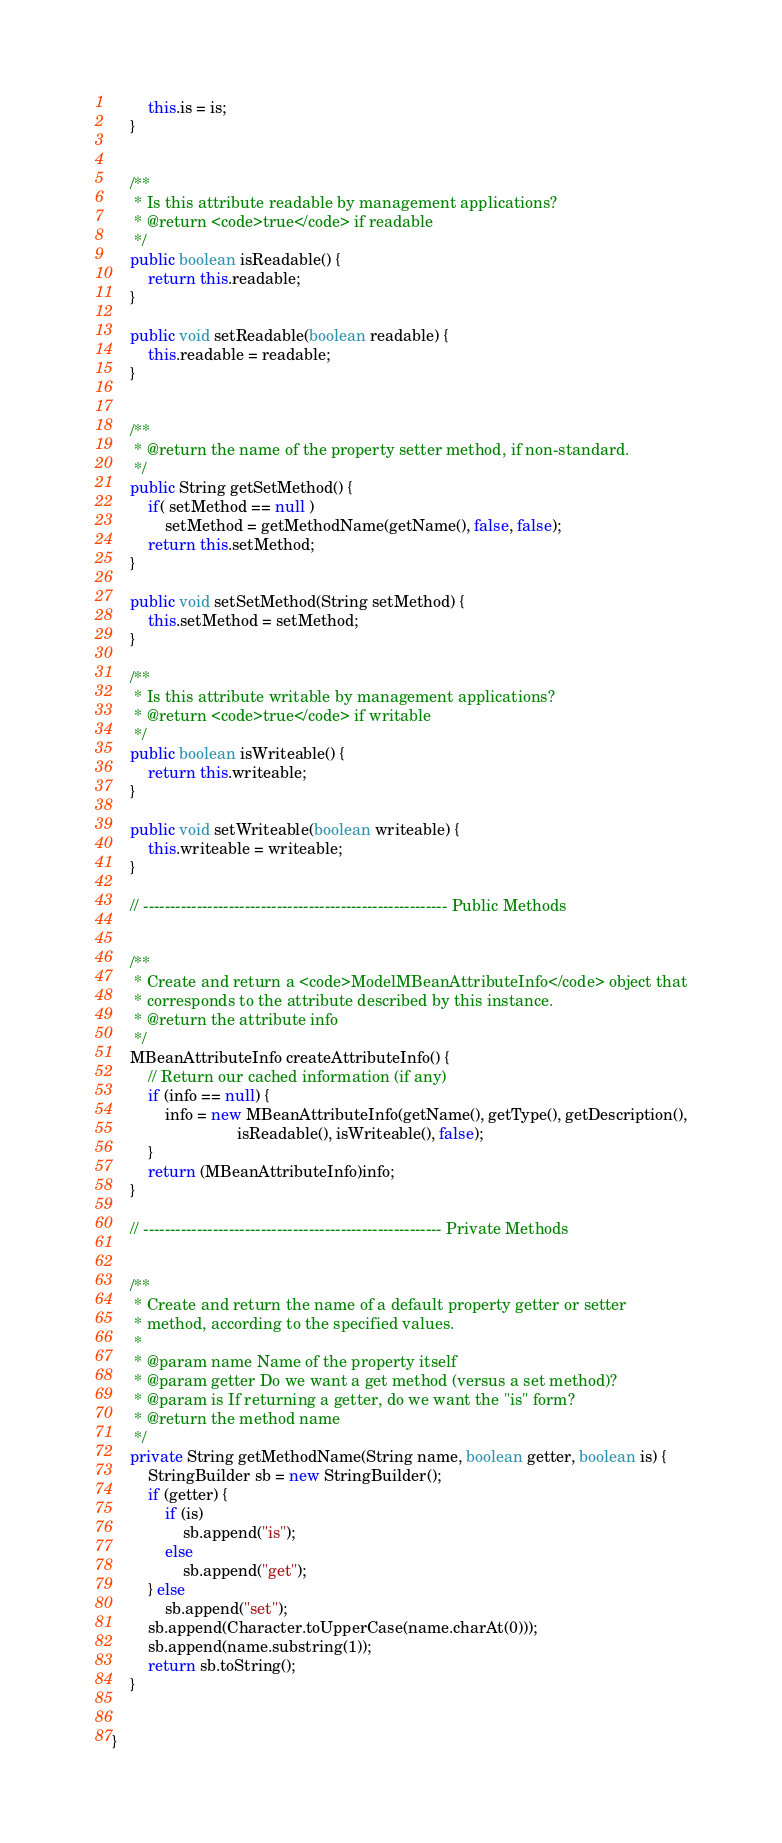<code> <loc_0><loc_0><loc_500><loc_500><_Java_>        this.is = is;
    }


    /**
     * Is this attribute readable by management applications?
     * @return <code>true</code> if readable
     */
    public boolean isReadable() {
        return this.readable;
    }

    public void setReadable(boolean readable) {
        this.readable = readable;
    }


    /**
     * @return the name of the property setter method, if non-standard.
     */
    public String getSetMethod() {
        if( setMethod == null )
            setMethod = getMethodName(getName(), false, false);
        return this.setMethod;
    }

    public void setSetMethod(String setMethod) {
        this.setMethod = setMethod;
    }

    /**
     * Is this attribute writable by management applications?
     * @return <code>true</code> if writable
     */
    public boolean isWriteable() {
        return this.writeable;
    }

    public void setWriteable(boolean writeable) {
        this.writeable = writeable;
    }

    // --------------------------------------------------------- Public Methods


    /**
     * Create and return a <code>ModelMBeanAttributeInfo</code> object that
     * corresponds to the attribute described by this instance.
     * @return the attribute info
     */
    MBeanAttributeInfo createAttributeInfo() {
        // Return our cached information (if any)
        if (info == null) {
            info = new MBeanAttributeInfo(getName(), getType(), getDescription(),
                            isReadable(), isWriteable(), false);
        }
        return (MBeanAttributeInfo)info;
    }

    // -------------------------------------------------------- Private Methods


    /**
     * Create and return the name of a default property getter or setter
     * method, according to the specified values.
     *
     * @param name Name of the property itself
     * @param getter Do we want a get method (versus a set method)?
     * @param is If returning a getter, do we want the "is" form?
     * @return the method name
     */
    private String getMethodName(String name, boolean getter, boolean is) {
        StringBuilder sb = new StringBuilder();
        if (getter) {
            if (is)
                sb.append("is");
            else
                sb.append("get");
        } else
            sb.append("set");
        sb.append(Character.toUpperCase(name.charAt(0)));
        sb.append(name.substring(1));
        return sb.toString();
    }


}
</code> 